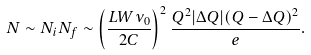<formula> <loc_0><loc_0><loc_500><loc_500>N \sim N _ { i } N _ { f } \sim \left ( \frac { L W \nu _ { 0 } } { 2 C } \right ) ^ { 2 } \frac { Q ^ { 2 } | \Delta Q | ( Q - \Delta Q ) ^ { 2 } } { e } .</formula> 